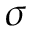Convert formula to latex. <formula><loc_0><loc_0><loc_500><loc_500>\sigma</formula> 